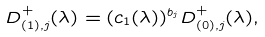Convert formula to latex. <formula><loc_0><loc_0><loc_500><loc_500>D _ { ( 1 ) , j } ^ { + } ( \lambda ) = ( c _ { 1 } ( \lambda ) ) ^ { b _ { j } } D _ { ( 0 ) , j } ^ { + } ( \lambda ) ,</formula> 